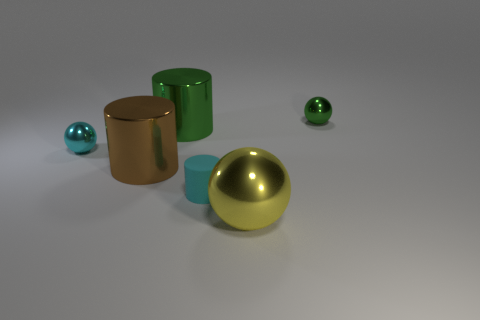How do the different materials of the objects affect how light is reflected? The materials of the objects in the image play a significant role in light reflection. The shiny ball reflects light smoothly and vividly, creating a distinct highlight and mirroring the environment, whereas the matte cylinders diffuse light, spreading it out evenly and softening the reflection on their surface. 